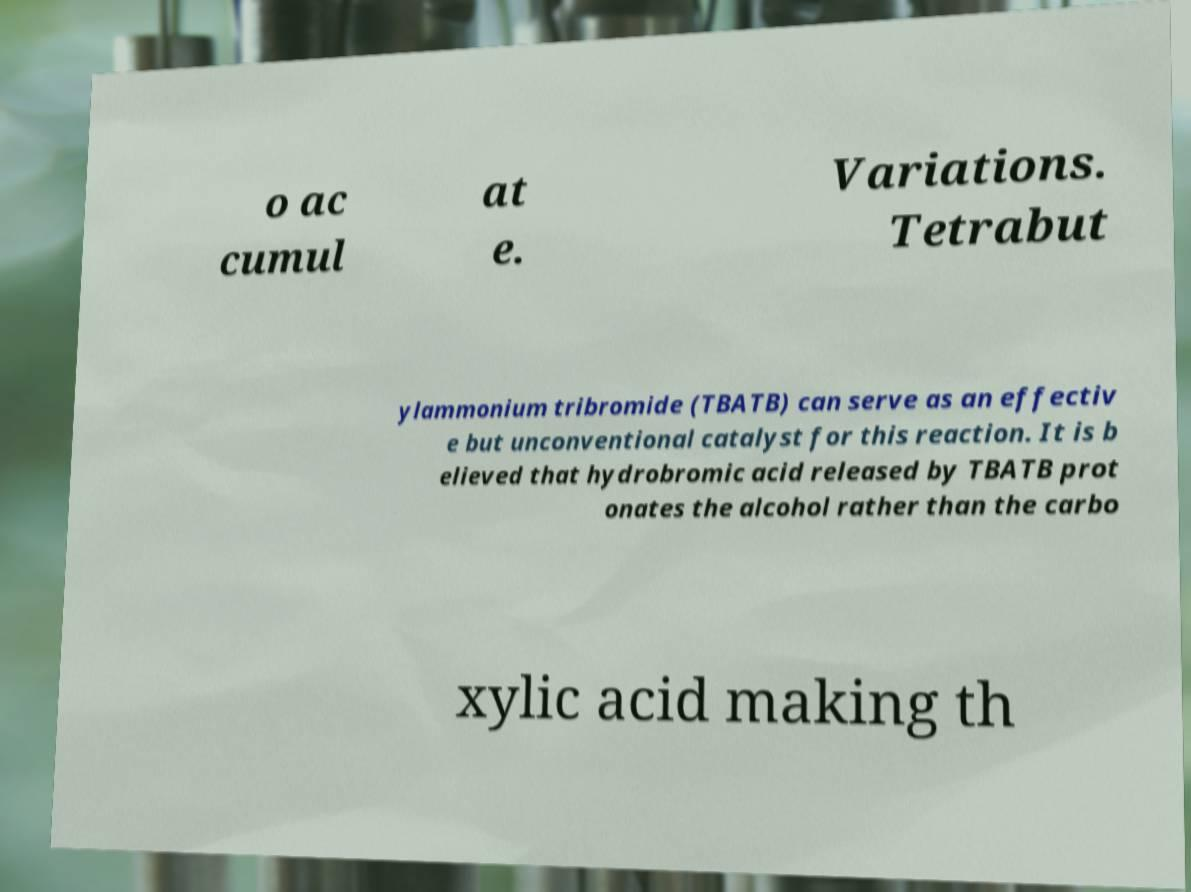Could you extract and type out the text from this image? o ac cumul at e. Variations. Tetrabut ylammonium tribromide (TBATB) can serve as an effectiv e but unconventional catalyst for this reaction. It is b elieved that hydrobromic acid released by TBATB prot onates the alcohol rather than the carbo xylic acid making th 